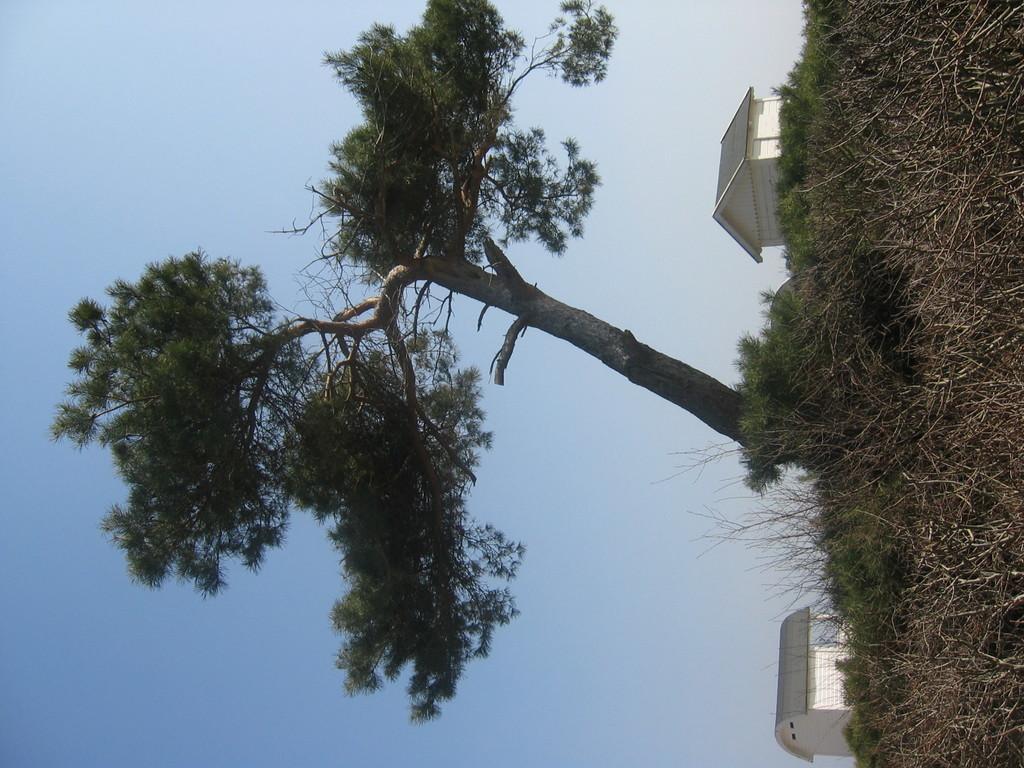Describe this image in one or two sentences. Here we can see houses, plants, and tree. In the background there is sky. 